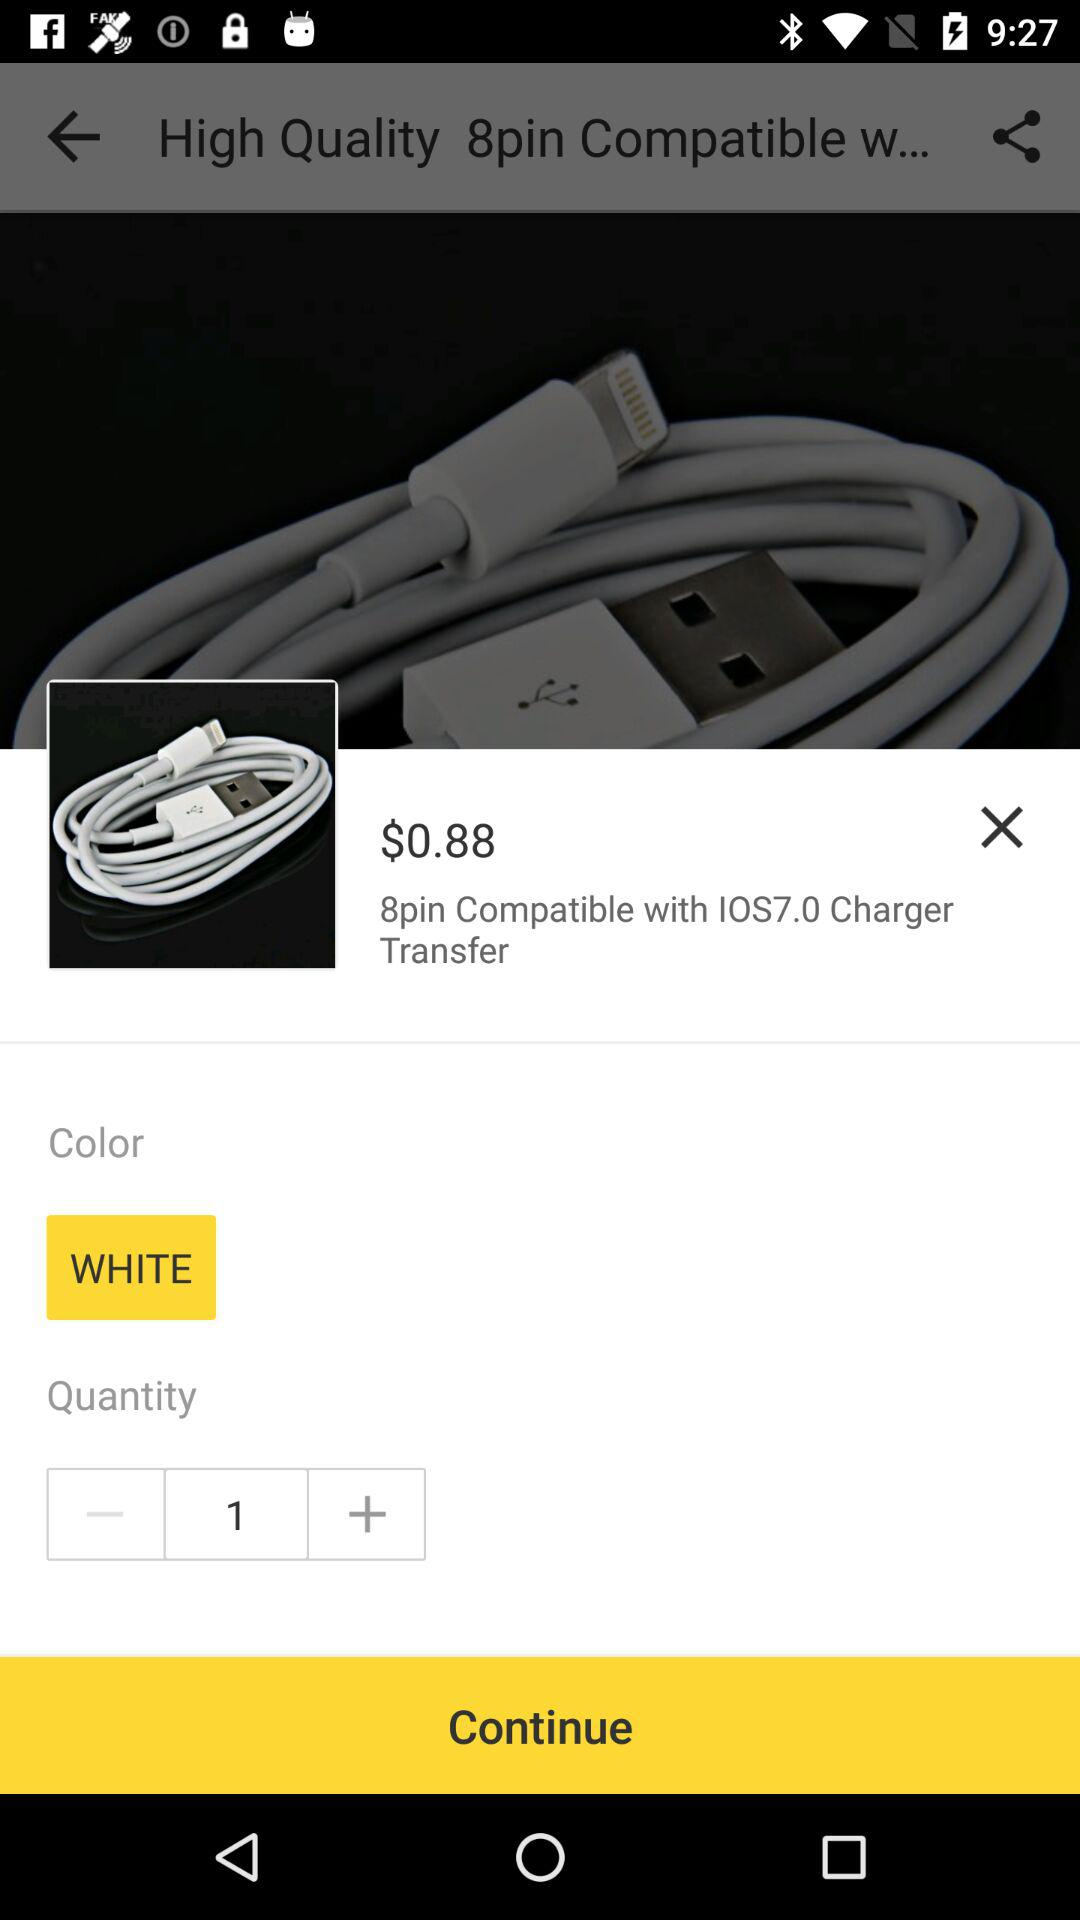What's the price of the charger? The price is $0.88. 